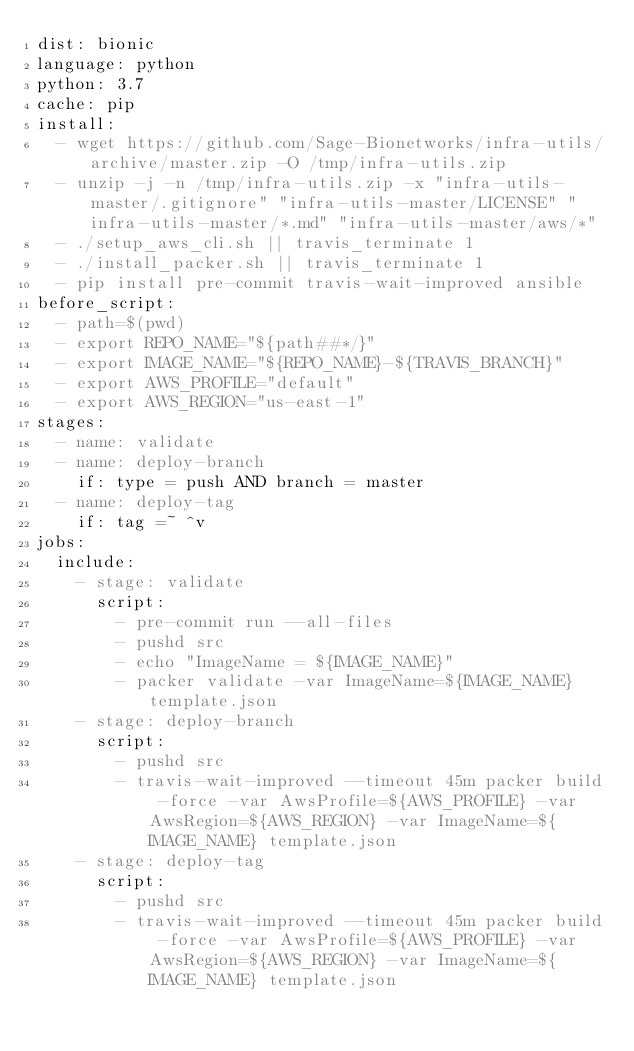<code> <loc_0><loc_0><loc_500><loc_500><_YAML_>dist: bionic
language: python
python: 3.7
cache: pip
install:
  - wget https://github.com/Sage-Bionetworks/infra-utils/archive/master.zip -O /tmp/infra-utils.zip
  - unzip -j -n /tmp/infra-utils.zip -x "infra-utils-master/.gitignore" "infra-utils-master/LICENSE" "infra-utils-master/*.md" "infra-utils-master/aws/*"
  - ./setup_aws_cli.sh || travis_terminate 1
  - ./install_packer.sh || travis_terminate 1
  - pip install pre-commit travis-wait-improved ansible
before_script:
  - path=$(pwd)
  - export REPO_NAME="${path##*/}"
  - export IMAGE_NAME="${REPO_NAME}-${TRAVIS_BRANCH}"
  - export AWS_PROFILE="default"
  - export AWS_REGION="us-east-1"
stages:
  - name: validate
  - name: deploy-branch
    if: type = push AND branch = master
  - name: deploy-tag
    if: tag =~ ^v
jobs:
  include:
    - stage: validate
      script:
        - pre-commit run --all-files
        - pushd src
        - echo "ImageName = ${IMAGE_NAME}"
        - packer validate -var ImageName=${IMAGE_NAME} template.json
    - stage: deploy-branch
      script:
        - pushd src
        - travis-wait-improved --timeout 45m packer build -force -var AwsProfile=${AWS_PROFILE} -var AwsRegion=${AWS_REGION} -var ImageName=${IMAGE_NAME} template.json
    - stage: deploy-tag
      script:
        - pushd src
        - travis-wait-improved --timeout 45m packer build -force -var AwsProfile=${AWS_PROFILE} -var AwsRegion=${AWS_REGION} -var ImageName=${IMAGE_NAME} template.json
</code> 